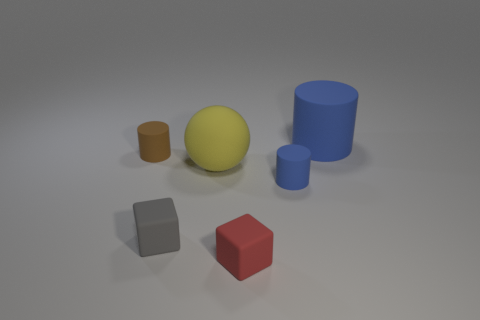Add 4 red things. How many objects exist? 10 Subtract all spheres. How many objects are left? 5 Subtract all big matte balls. Subtract all blue things. How many objects are left? 3 Add 3 red rubber cubes. How many red rubber cubes are left? 4 Add 1 small matte objects. How many small matte objects exist? 5 Subtract 0 brown blocks. How many objects are left? 6 